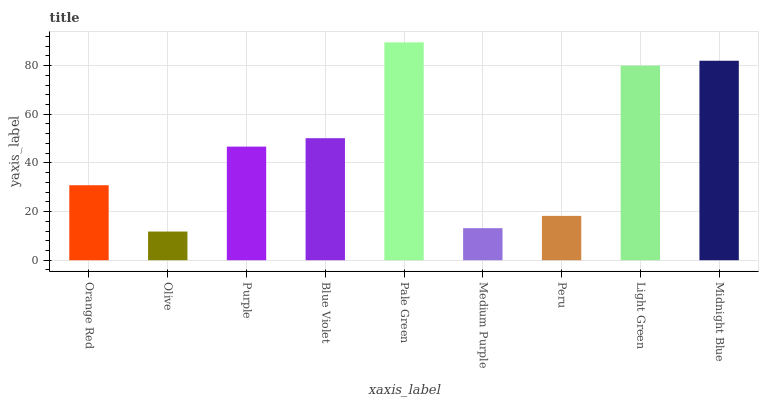Is Olive the minimum?
Answer yes or no. Yes. Is Pale Green the maximum?
Answer yes or no. Yes. Is Purple the minimum?
Answer yes or no. No. Is Purple the maximum?
Answer yes or no. No. Is Purple greater than Olive?
Answer yes or no. Yes. Is Olive less than Purple?
Answer yes or no. Yes. Is Olive greater than Purple?
Answer yes or no. No. Is Purple less than Olive?
Answer yes or no. No. Is Purple the high median?
Answer yes or no. Yes. Is Purple the low median?
Answer yes or no. Yes. Is Olive the high median?
Answer yes or no. No. Is Pale Green the low median?
Answer yes or no. No. 